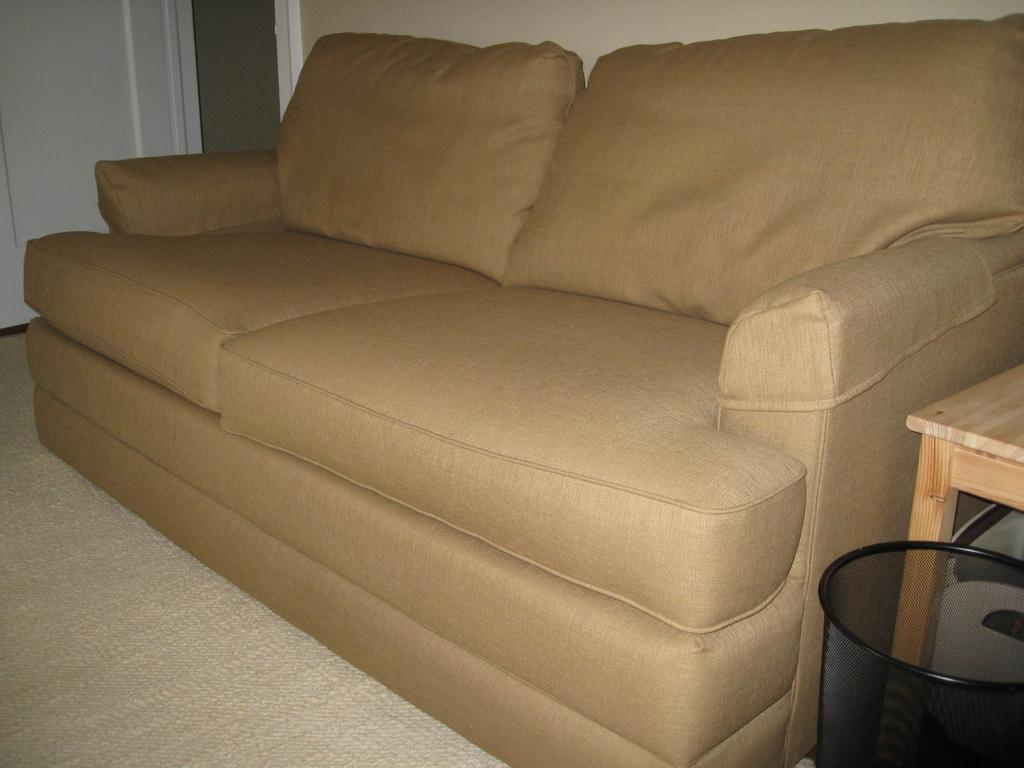What type of furniture is present in the image? There is a couch and a table in the image. What is located on the floor in the image? There is a container on the floor in the image. What architectural feature can be seen in the image? There is a door in the image. What type of structure is visible in the image? There is a wall in the image. What type of development can be seen taking place in the image? There is no development taking place in the image; it features a couch, table, container, door, and wall. Can you tell me how many baskets are visible in the image? There are no baskets present in the image. 